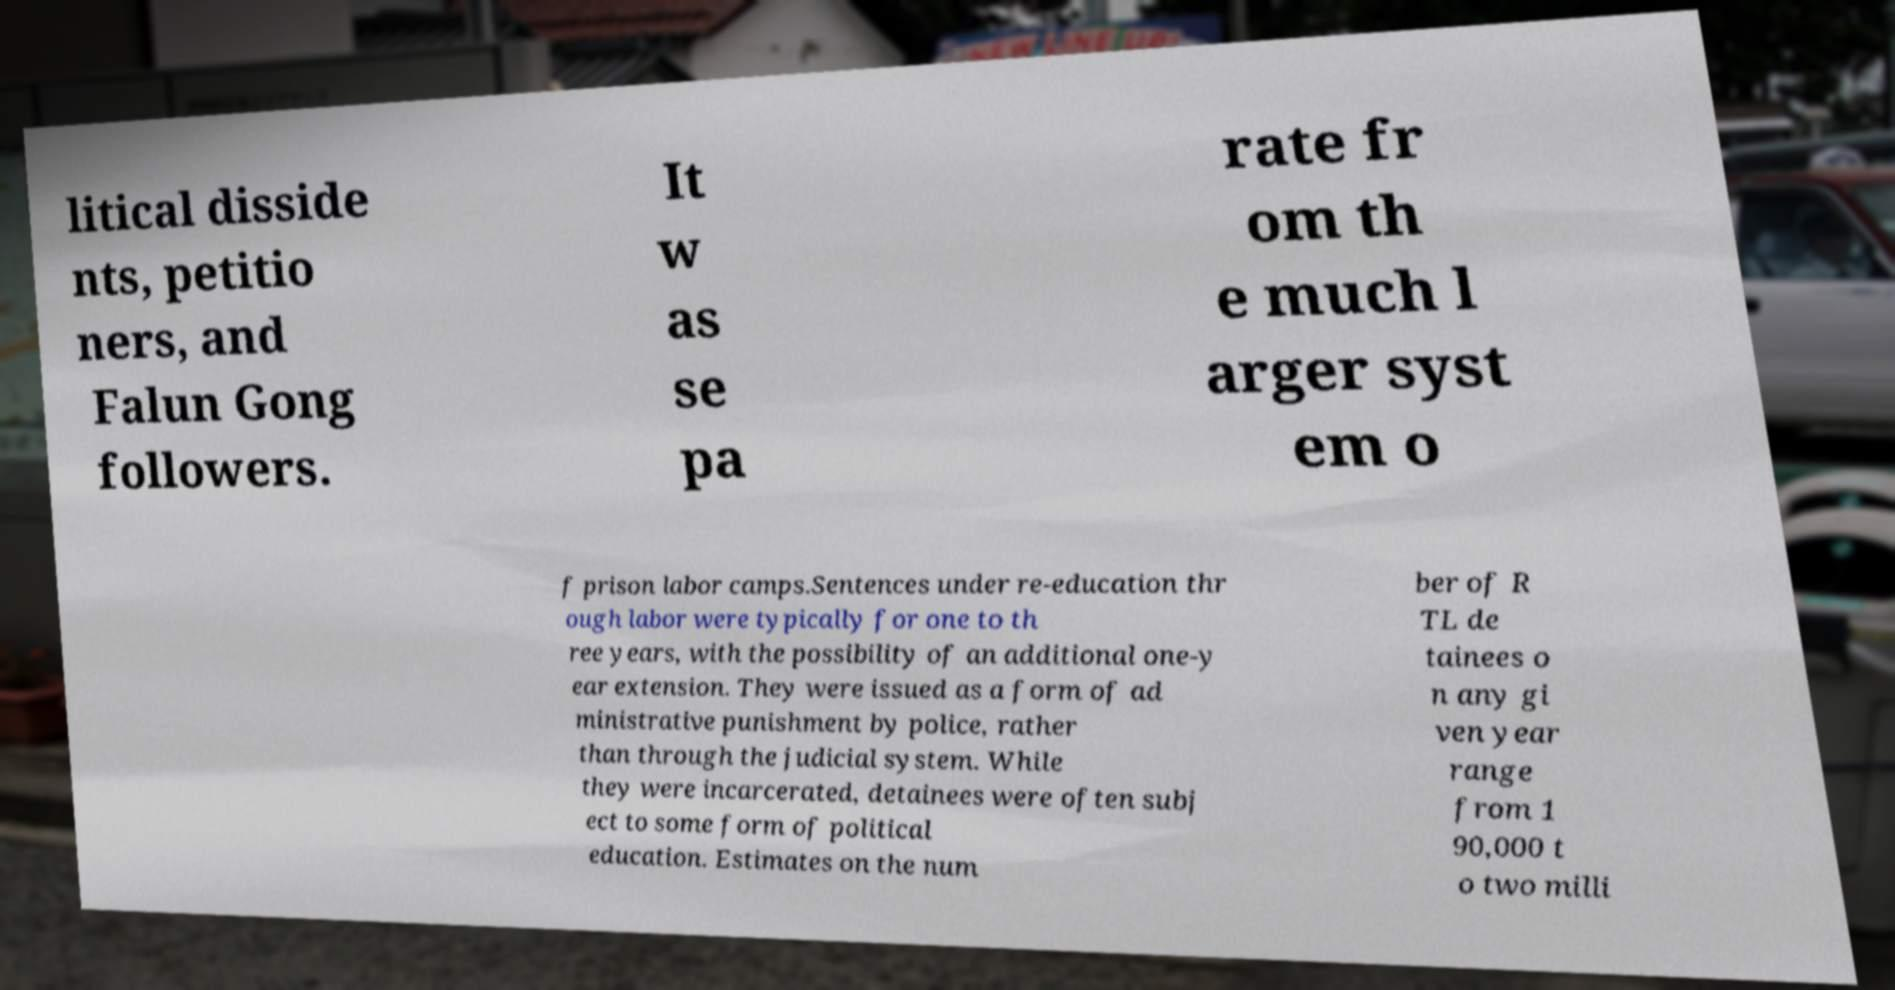Can you accurately transcribe the text from the provided image for me? litical disside nts, petitio ners, and Falun Gong followers. It w as se pa rate fr om th e much l arger syst em o f prison labor camps.Sentences under re-education thr ough labor were typically for one to th ree years, with the possibility of an additional one-y ear extension. They were issued as a form of ad ministrative punishment by police, rather than through the judicial system. While they were incarcerated, detainees were often subj ect to some form of political education. Estimates on the num ber of R TL de tainees o n any gi ven year range from 1 90,000 t o two milli 